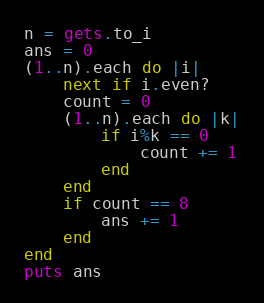<code> <loc_0><loc_0><loc_500><loc_500><_Ruby_>n = gets.to_i
ans = 0
(1..n).each do |i|
    next if i.even?
    count = 0
    (1..n).each do |k|
        if i%k == 0
            count += 1
        end 
    end 
    if count == 8
        ans += 1
    end 
end
puts ans</code> 